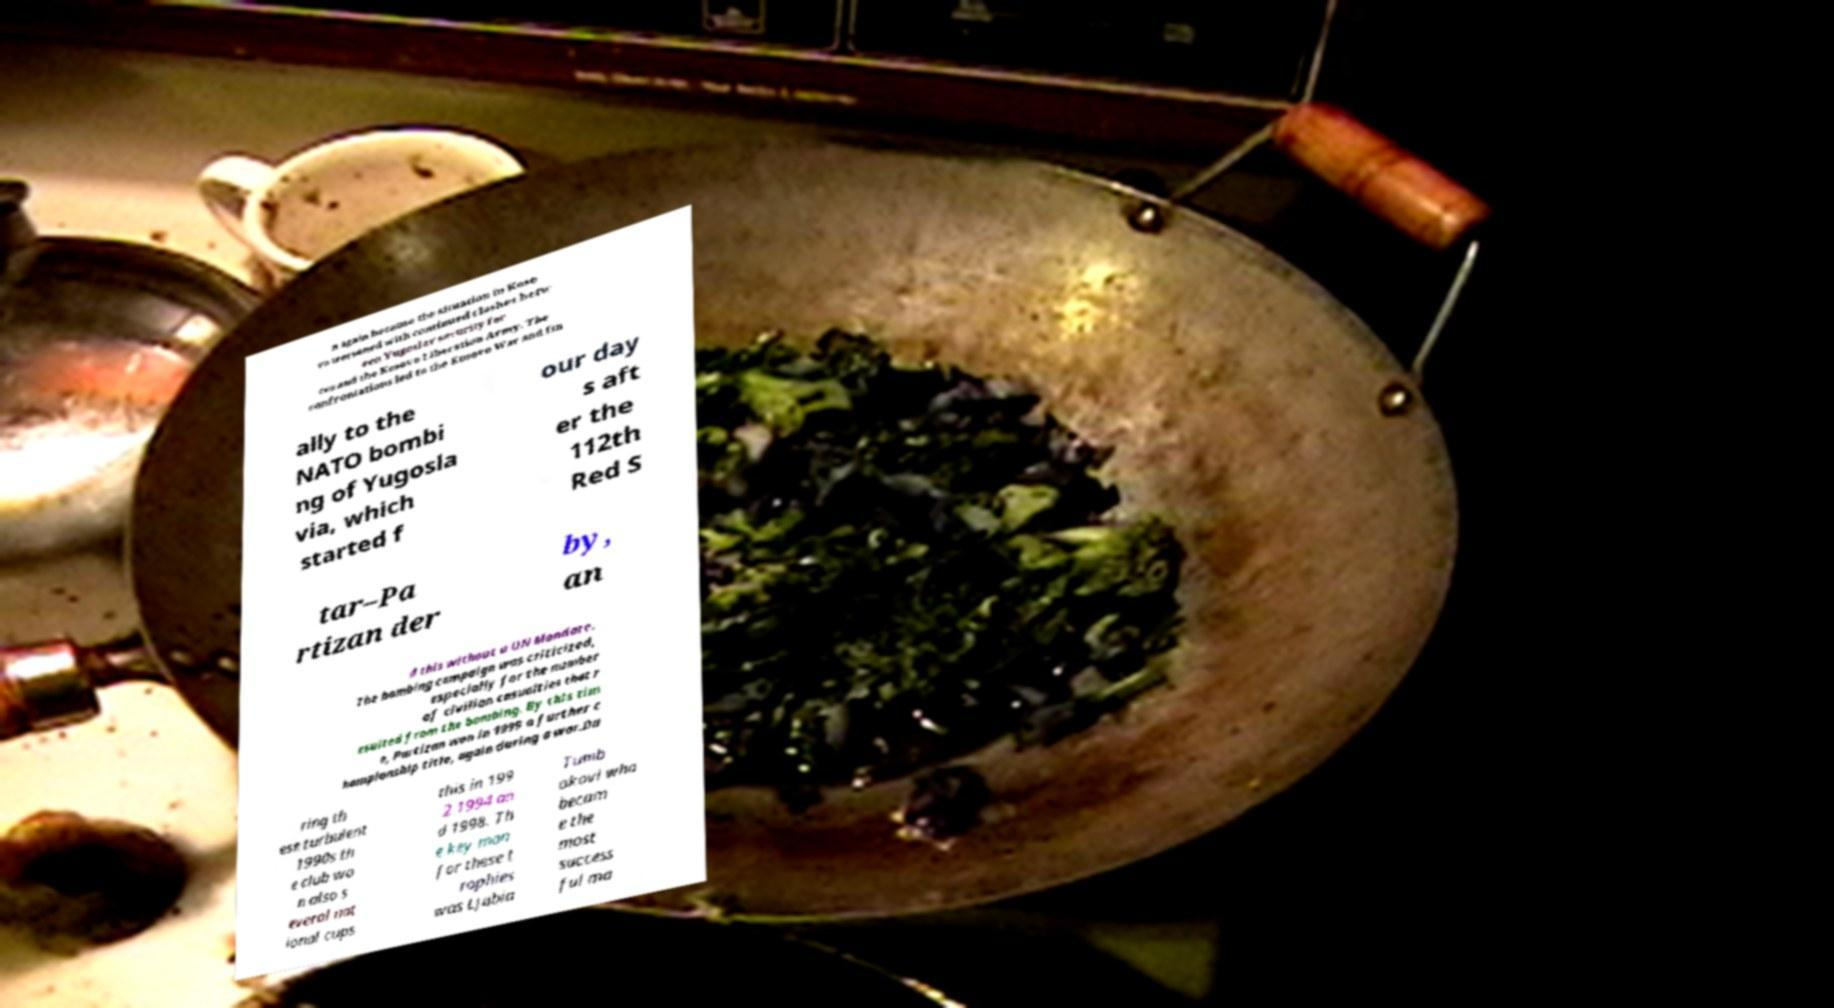Could you assist in decoding the text presented in this image and type it out clearly? n again because the situation in Koso vo worsened with continued clashes betw een Yugoslav security for ces and the Kosovo Liberation Army. The confrontations led to the Kosovo War and fin ally to the NATO bombi ng of Yugosla via, which started f our day s aft er the 112th Red S tar–Pa rtizan der by, an d this without a UN Mandate. The bombing campaign was criticized, especially for the number of civilian casualties that r esulted from the bombing. By this tim e, Partizan won in 1999 a further c hampionship title, again during a war.Du ring th ese turbulent 1990s th e club wo n also s everal nat ional cups this in 199 2 1994 an d 1998. Th e key man for these t rophies was Ljubia Tumb akovi who becam e the most success ful ma 